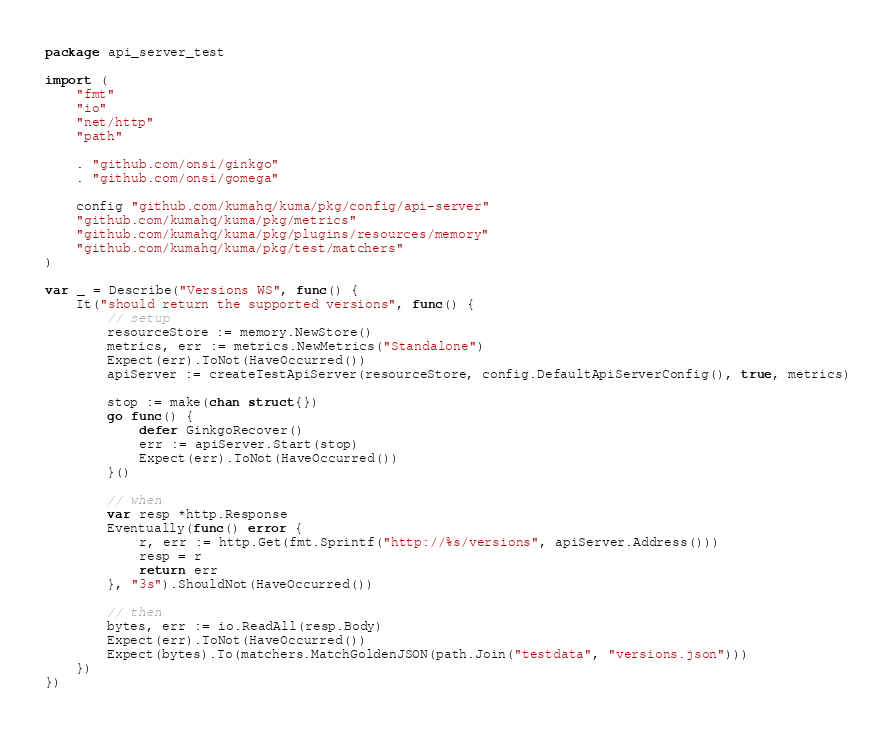<code> <loc_0><loc_0><loc_500><loc_500><_Go_>package api_server_test

import (
	"fmt"
	"io"
	"net/http"
	"path"

	. "github.com/onsi/ginkgo"
	. "github.com/onsi/gomega"

	config "github.com/kumahq/kuma/pkg/config/api-server"
	"github.com/kumahq/kuma/pkg/metrics"
	"github.com/kumahq/kuma/pkg/plugins/resources/memory"
	"github.com/kumahq/kuma/pkg/test/matchers"
)

var _ = Describe("Versions WS", func() {
	It("should return the supported versions", func() {
		// setup
		resourceStore := memory.NewStore()
		metrics, err := metrics.NewMetrics("Standalone")
		Expect(err).ToNot(HaveOccurred())
		apiServer := createTestApiServer(resourceStore, config.DefaultApiServerConfig(), true, metrics)

		stop := make(chan struct{})
		go func() {
			defer GinkgoRecover()
			err := apiServer.Start(stop)
			Expect(err).ToNot(HaveOccurred())
		}()

		// when
		var resp *http.Response
		Eventually(func() error {
			r, err := http.Get(fmt.Sprintf("http://%s/versions", apiServer.Address()))
			resp = r
			return err
		}, "3s").ShouldNot(HaveOccurred())

		// then
		bytes, err := io.ReadAll(resp.Body)
		Expect(err).ToNot(HaveOccurred())
		Expect(bytes).To(matchers.MatchGoldenJSON(path.Join("testdata", "versions.json")))
	})
})
</code> 